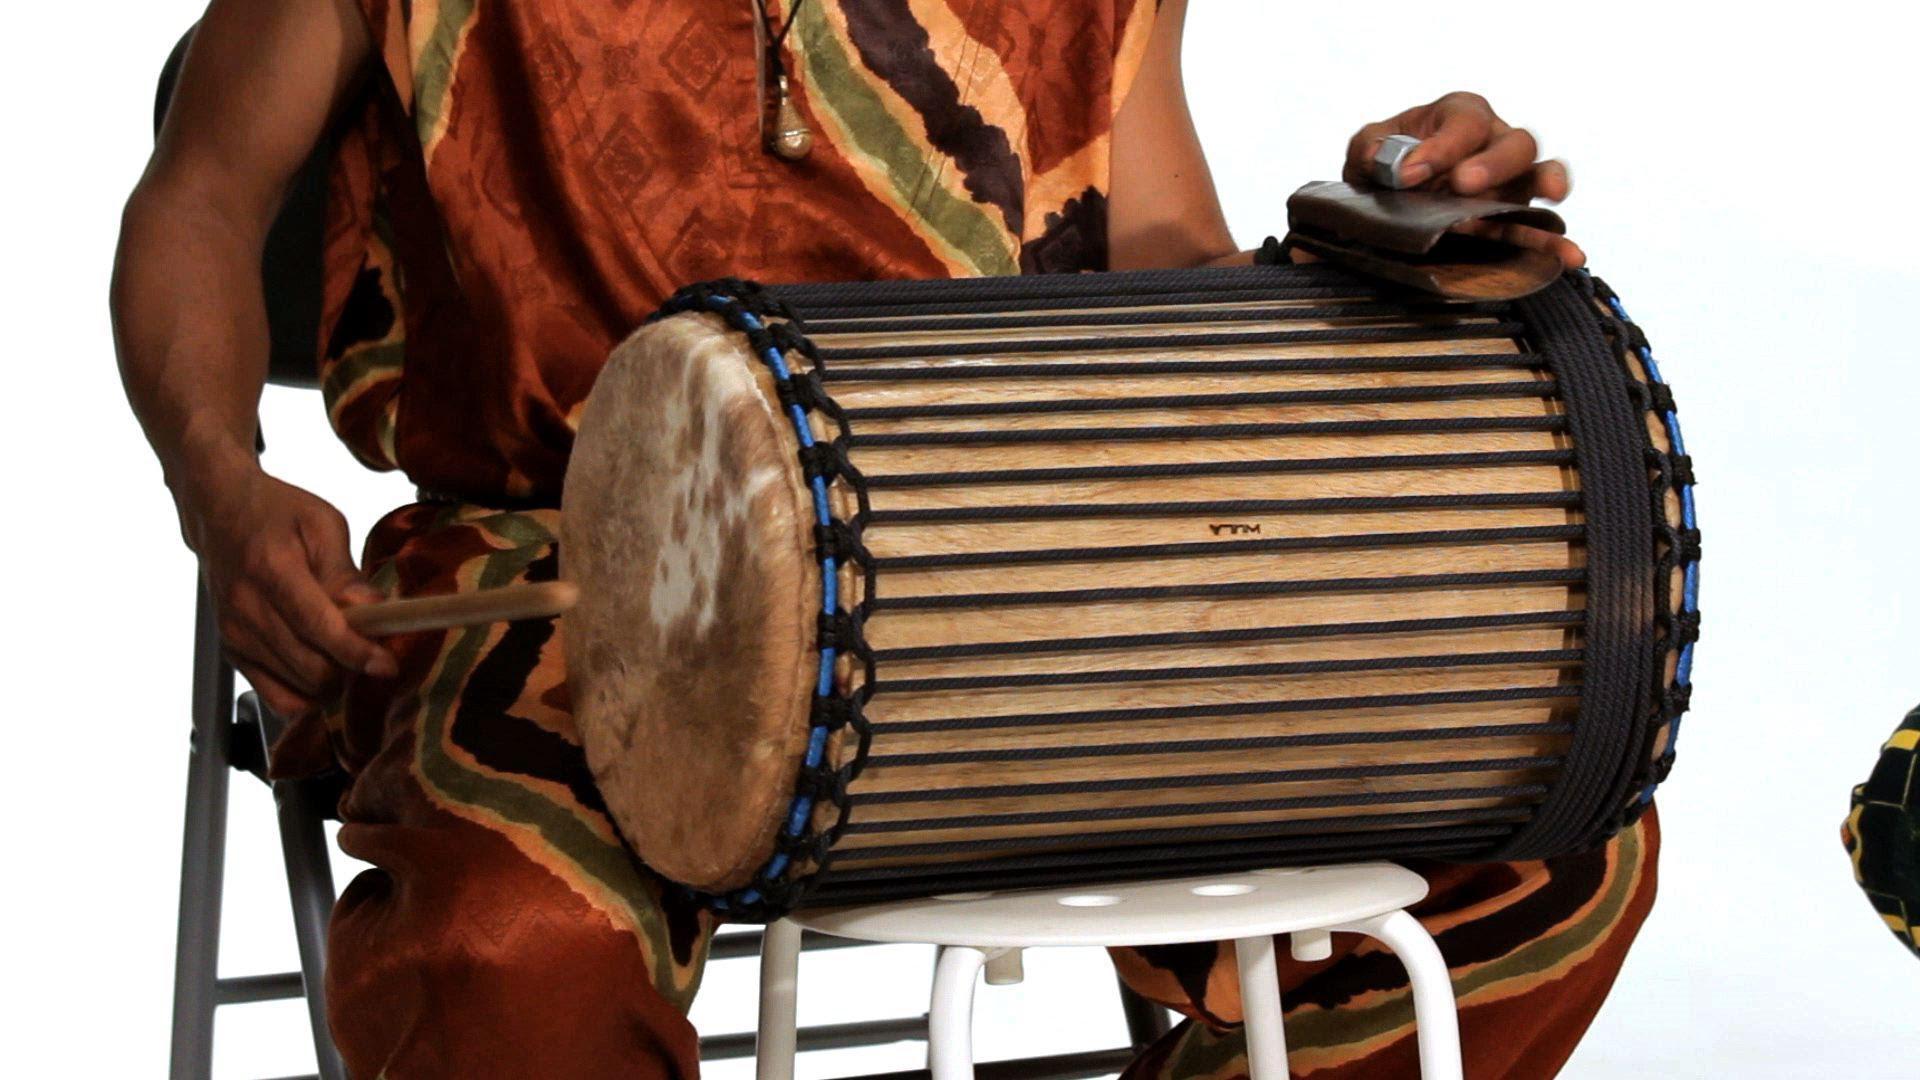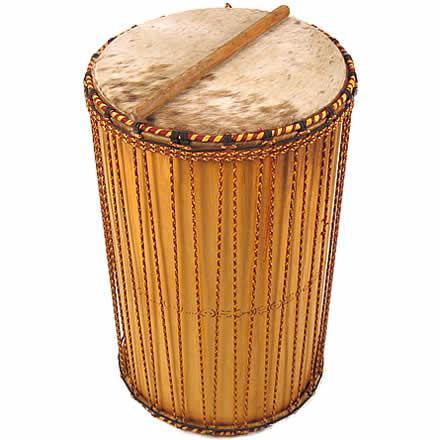The first image is the image on the left, the second image is the image on the right. Examine the images to the left and right. Is the description "There are at least four drums." accurate? Answer yes or no. No. The first image is the image on the left, the second image is the image on the right. Given the left and right images, does the statement "One image shows three close-together upright drums, with two standing in front and a bigger one behind them." hold true? Answer yes or no. No. 